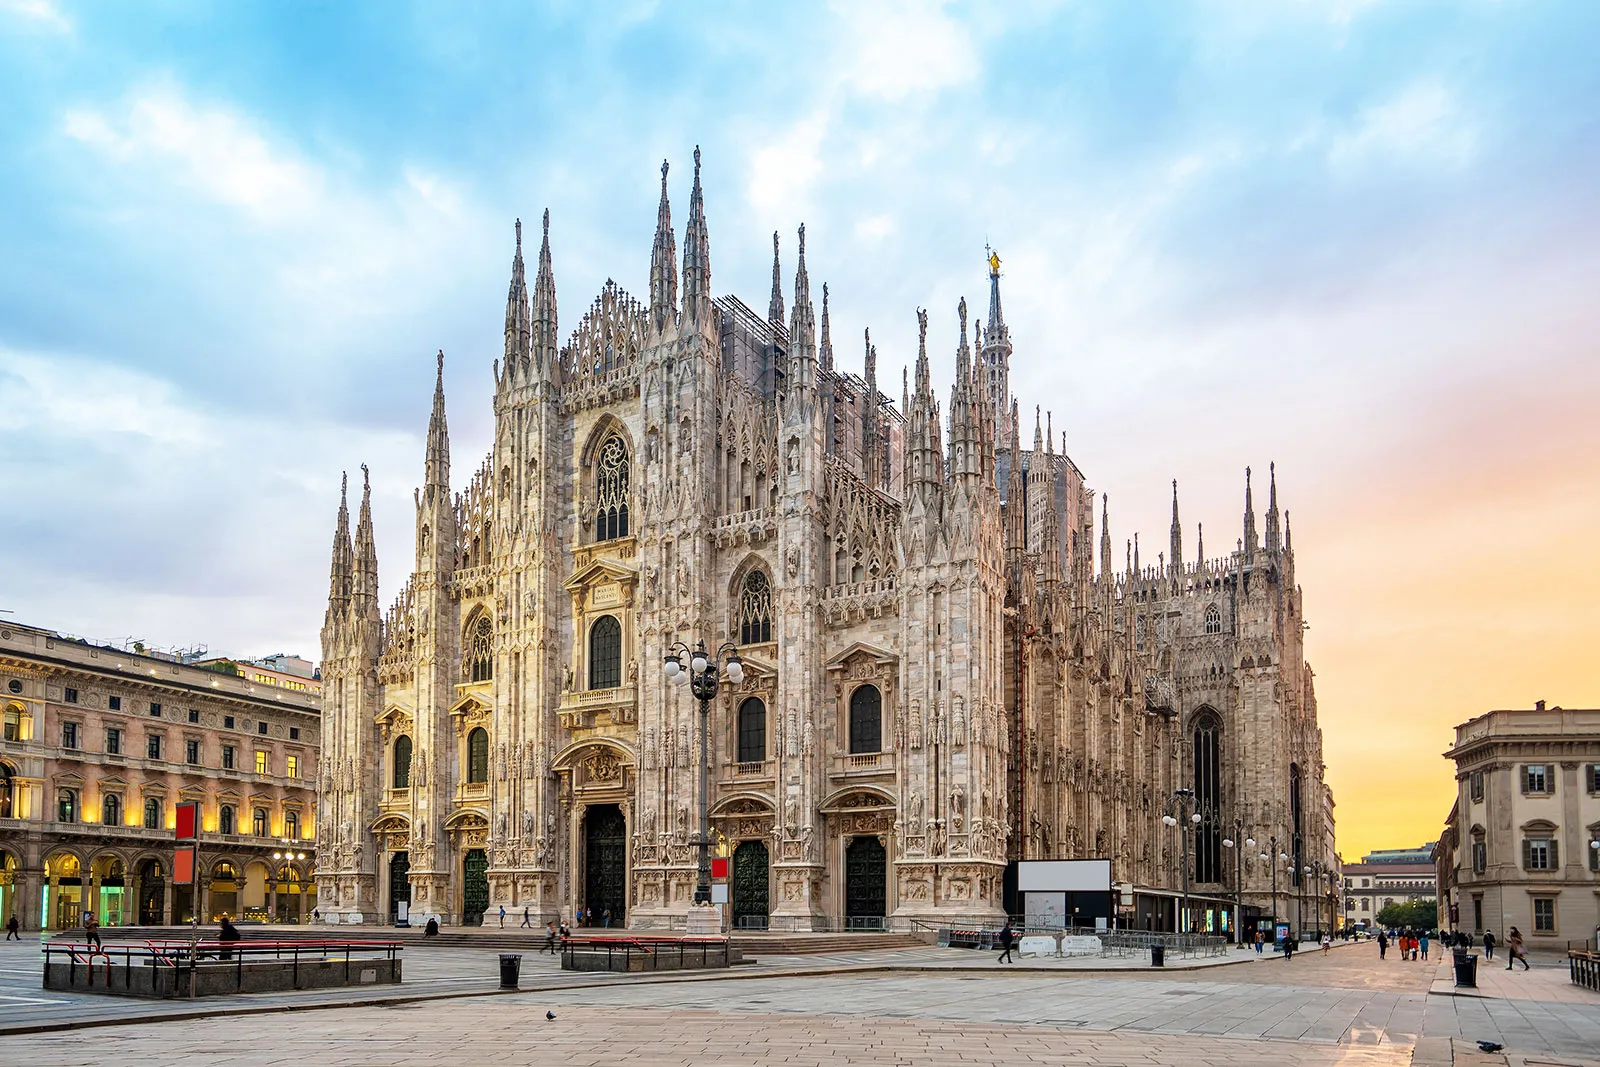What can you infer about the atmosphere and the activities around the cathedral at the time the photo was taken? The relatively empty square in front of the Milan Cathedral suggests a peaceful and quiet atmosphere, possibly early in the morning or late in the evening when fewer tourists are present. The absence of crowds allows for an unobstructed view of the cathedral, emphasizing its grandeur and serene presence. Can you describe a possible scenario of a festive event taking place in this square? Imagine a festive event where the square in front of the Milan Cathedral is filled with people, vibrant decorations, and lively music. Colorful banners and lights adorn the cathedral’s façade, enhancing its majestic appearance. Stalls offering traditional Italian food and crafts line the perimeter, and the atmosphere is abuzz with excitement and joy. The grand spires of the cathedral overlook the celebrations, as if participating in the festivity, adding a sense of timelessness to the joyous occasion. What if the cathedral could talk? What story would it tell about its history? If the Milan Cathedral could talk, it would recount tales of its construction starting in the 14th century, involving numerous architects, artisans, and laborers over the centuries. It would share stories of the countless events it has witnessed, from religious ceremonies and royal visits to moments of solitude and reflection under the changing skies. It would speak of the wear and resilience of its marble as it has stood the test of time, embodying the spirit and history of Milan in every spire and stone. 